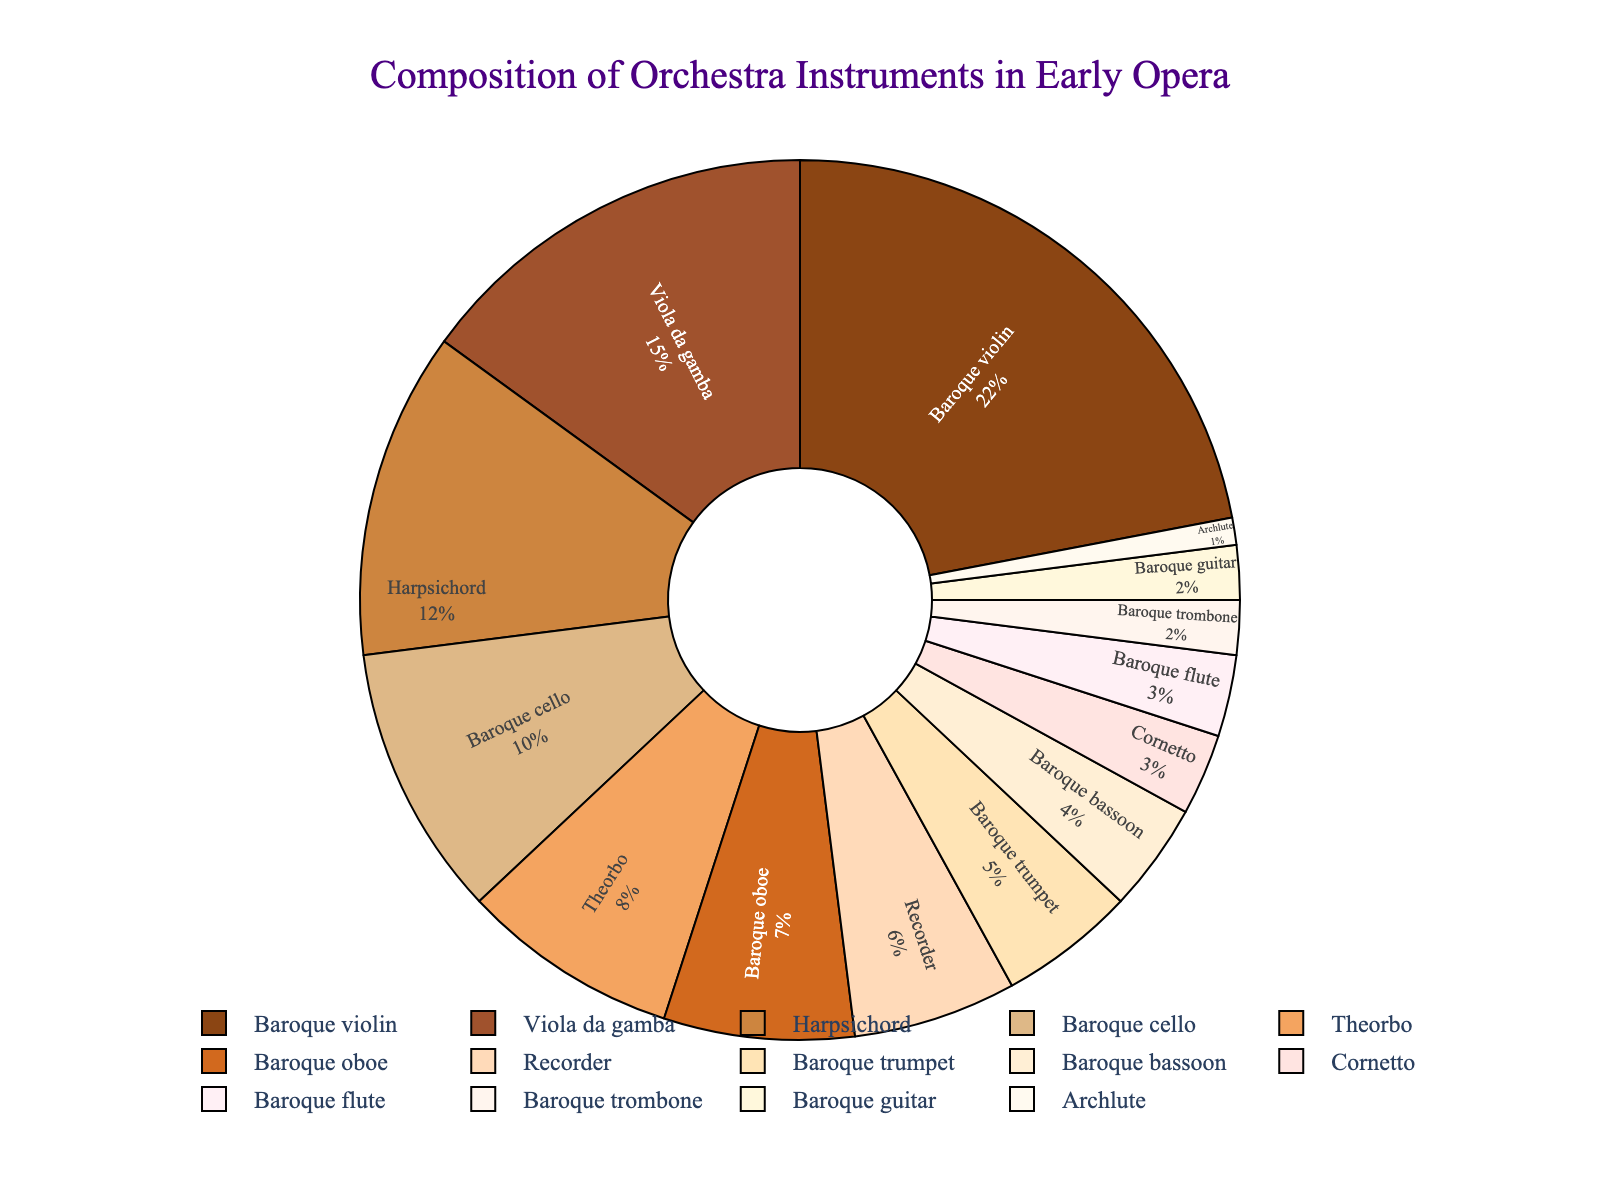Which instrument has the highest percentage in the orchestra composition? The pie chart shows the percentage of different instruments used. The largest portion is labeled "Baroque violin" with 22%.
Answer: Baroque violin What is the combined percentage of Baroque cello and Baroque oboe? The chart shows the Baroque cello at 10% and the Baroque oboe at 7%. Adding these two percentages gives 10% + 7% = 17%.
Answer: 17% What percentage of the orchestra is composed of string instruments (Baroque violin, Viola da gamba, Baroque cello)? The percentages for string instruments are Baroque violin (22%), Viola da gamba (15%), and Baroque cello (10%). Adding these gives 22% + 15% + 10% = 47%.
Answer: 47% Which instrument has the smallest percentage, and what is that percentage? The pie chart shows the Archlute segment as the smallest, labeled with 1%.
Answer: Archlute, 1% Compare the percentage of Baroque flute and Cornetto. Which one has a higher percentage and by how much? Baroque flute is 3% and Cornetto is also 3%. The difference is 0%. Therefore, neither is higher.
Answer: Neither, 0% How many instruments have a percentage greater than or equal to 10%? Instruments meeting this criteria are Baroque violin (22%), Viola da gamba (15%), Harpsichord (12%), and Baroque cello (10%), totaling 4 instruments.
Answer: 4 What is the total percentage of the wind instruments (Recorder, Baroque oboe, Baroque trumpet, Baroque bassoon, Cornetto, Baroque flute, Baroque trombone)? The listed wind instruments have percentages: Recorder (6%), Baroque oboe (7%), Baroque trumpet (5%), Baroque bassoon (4%), Cornetto (3%), Baroque flute (3%), Baroque trombone (2%). Adding these gives 6% + 7% + 5% + 4% + 3% + 3% + 2% = 30%.
Answer: 30% Which instrument represented by a light color has an 8% composition? The Theorbo has an 8% composition and is represented in a lighter color.
Answer: Theorbo How does the percentage of the Harpsichord compare to the combined percentage of Baroque trombone and Baroque guitar? Harpsichord is 12%, and the combined percentage of Baroque trombone (2%) and Baroque guitar (2%) is 4%. Harpsichord's percentage is greater by 12% - 4% = 8%.
Answer: Harpsichord, 8% If you sum the percentages of the lowest three instruments, what is the total? The three lowest percentages are Archlute (1%), Baroque guitar (2%), and Baroque trombone (2%). Summing these gives 1% + 2% + 2% = 5%.
Answer: 5% 